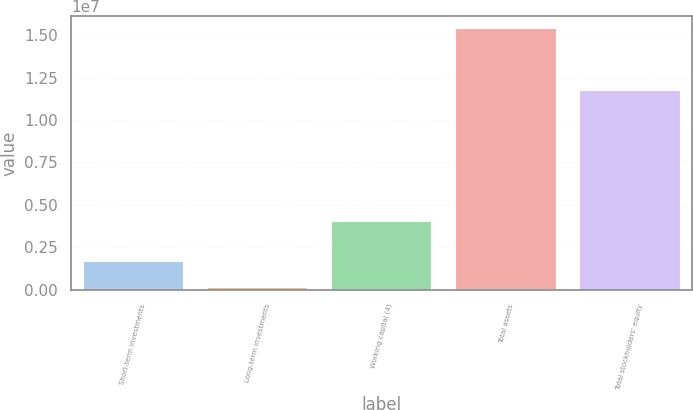Convert chart to OTSL. <chart><loc_0><loc_0><loc_500><loc_500><bar_chart><fcel>Short-term investments<fcel>Long-term investments<fcel>Working capital (4)<fcel>Total assets<fcel>Total stockholders' equity<nl><fcel>1.66102e+06<fcel>138237<fcel>4.02293e+06<fcel>1.5366e+07<fcel>1.17046e+07<nl></chart> 